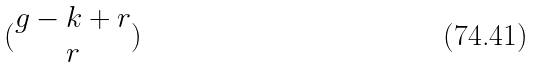<formula> <loc_0><loc_0><loc_500><loc_500>( \begin{matrix} g - k + r \\ r \end{matrix} )</formula> 